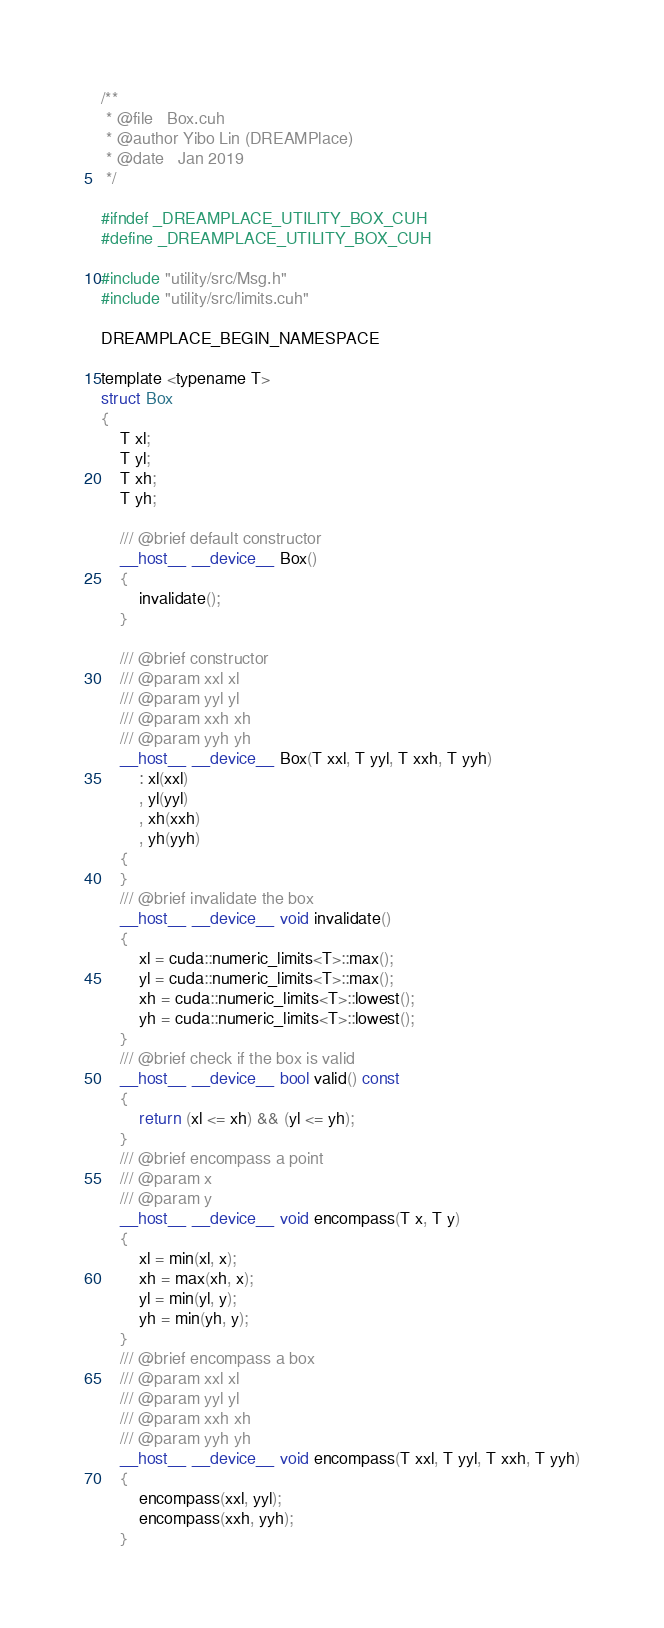Convert code to text. <code><loc_0><loc_0><loc_500><loc_500><_Cuda_>/**
 * @file   Box.cuh
 * @author Yibo Lin (DREAMPlace)
 * @date   Jan 2019
 */

#ifndef _DREAMPLACE_UTILITY_BOX_CUH
#define _DREAMPLACE_UTILITY_BOX_CUH

#include "utility/src/Msg.h"
#include "utility/src/limits.cuh"

DREAMPLACE_BEGIN_NAMESPACE

template <typename T>
struct Box 
{
    T xl;
    T yl; 
    T xh; 
    T yh; 

    /// @brief default constructor 
    __host__ __device__ Box()
    {
        invalidate();
    }

    /// @brief constructor 
    /// @param xxl xl 
    /// @param yyl yl 
    /// @param xxh xh 
    /// @param yyh yh 
    __host__ __device__ Box(T xxl, T yyl, T xxh, T yyh)
        : xl(xxl)
        , yl(yyl)
        , xh(xxh)
        , yh(yyh)
    {
    }
    /// @brief invalidate the box 
    __host__ __device__ void invalidate()
    {
        xl = cuda::numeric_limits<T>::max(); 
        yl = cuda::numeric_limits<T>::max(); 
        xh = cuda::numeric_limits<T>::lowest(); 
        yh = cuda::numeric_limits<T>::lowest(); 
    }
    /// @brief check if the box is valid 
    __host__ __device__ bool valid() const 
    {
        return (xl <= xh) && (yl <= yh);
    }
    /// @brief encompass a point 
    /// @param x 
    /// @param y
    __host__ __device__ void encompass(T x, T y)
    {
        xl = min(xl, x); 
        xh = max(xh, x); 
        yl = min(yl, y); 
        yh = min(yh, y);
    }
    /// @brief encompass a box 
    /// @param xxl xl 
    /// @param yyl yl 
    /// @param xxh xh 
    /// @param yyh yh 
    __host__ __device__ void encompass(T xxl, T yyl, T xxh, T yyh)
    {
        encompass(xxl, yyl);
        encompass(xxh, yyh);
    }</code> 